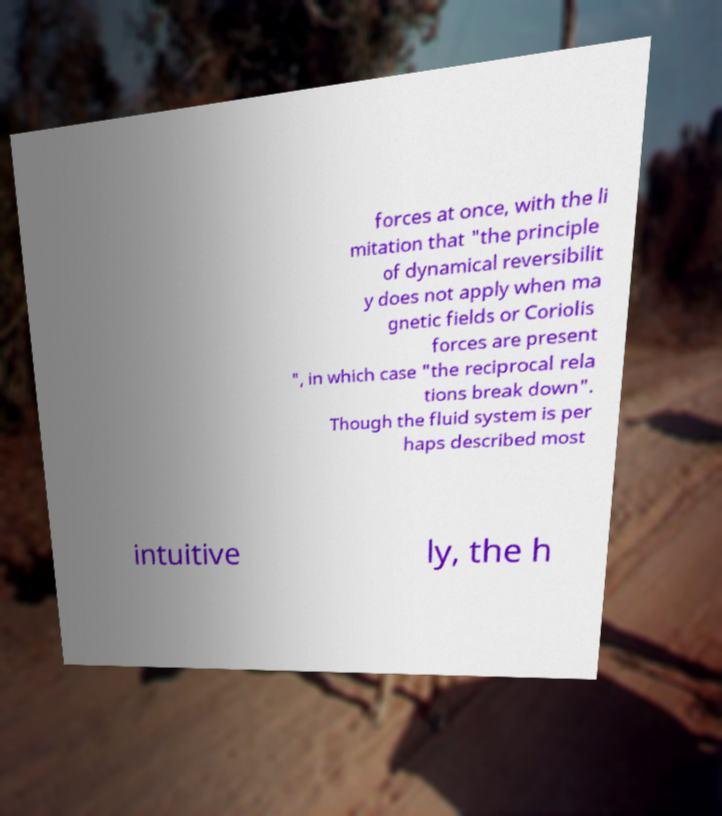Can you accurately transcribe the text from the provided image for me? forces at once, with the li mitation that "the principle of dynamical reversibilit y does not apply when ma gnetic fields or Coriolis forces are present ", in which case "the reciprocal rela tions break down". Though the fluid system is per haps described most intuitive ly, the h 